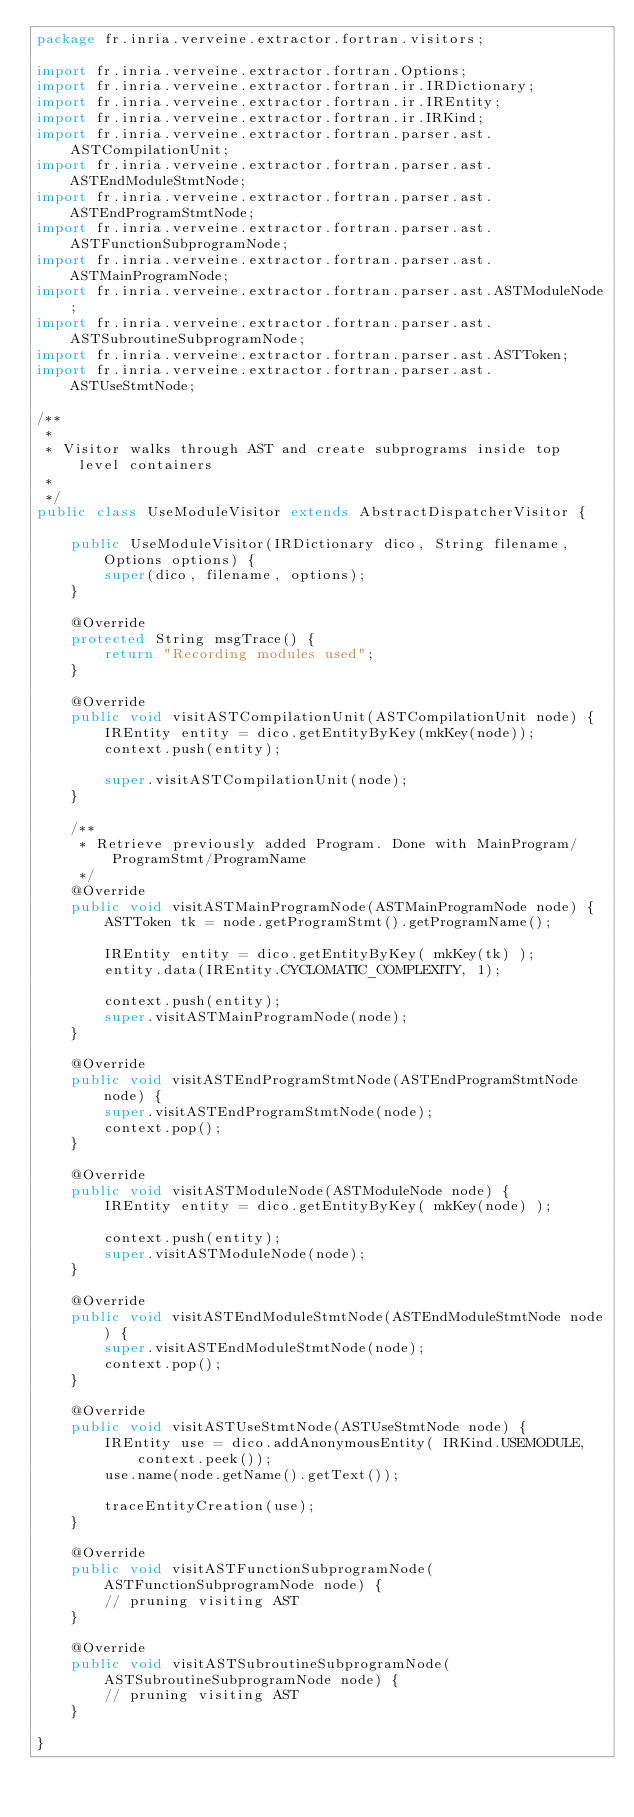<code> <loc_0><loc_0><loc_500><loc_500><_Java_>package fr.inria.verveine.extractor.fortran.visitors;

import fr.inria.verveine.extractor.fortran.Options;
import fr.inria.verveine.extractor.fortran.ir.IRDictionary;
import fr.inria.verveine.extractor.fortran.ir.IREntity;
import fr.inria.verveine.extractor.fortran.ir.IRKind;
import fr.inria.verveine.extractor.fortran.parser.ast.ASTCompilationUnit;
import fr.inria.verveine.extractor.fortran.parser.ast.ASTEndModuleStmtNode;
import fr.inria.verveine.extractor.fortran.parser.ast.ASTEndProgramStmtNode;
import fr.inria.verveine.extractor.fortran.parser.ast.ASTFunctionSubprogramNode;
import fr.inria.verveine.extractor.fortran.parser.ast.ASTMainProgramNode;
import fr.inria.verveine.extractor.fortran.parser.ast.ASTModuleNode;
import fr.inria.verveine.extractor.fortran.parser.ast.ASTSubroutineSubprogramNode;
import fr.inria.verveine.extractor.fortran.parser.ast.ASTToken;
import fr.inria.verveine.extractor.fortran.parser.ast.ASTUseStmtNode;

/**
 * 
 * Visitor walks through AST and create subprograms inside top level containers
 *
 */
public class UseModuleVisitor extends AbstractDispatcherVisitor {

	public UseModuleVisitor(IRDictionary dico, String filename, Options options) {
		super(dico, filename, options);
	}

	@Override
	protected String msgTrace() {
		return "Recording modules used";
	}

	@Override
	public void visitASTCompilationUnit(ASTCompilationUnit node) {
		IREntity entity = dico.getEntityByKey(mkKey(node));
		context.push(entity);

		super.visitASTCompilationUnit(node);
	}

	/**
	 * Retrieve previously added Program. Done with MainProgram/ProgramStmt/ProgramName
	 */
	@Override
	public void visitASTMainProgramNode(ASTMainProgramNode node) {
		ASTToken tk = node.getProgramStmt().getProgramName();

		IREntity entity = dico.getEntityByKey( mkKey(tk) );
		entity.data(IREntity.CYCLOMATIC_COMPLEXITY, 1);

		context.push(entity);
		super.visitASTMainProgramNode(node);
	}

	@Override
	public void visitASTEndProgramStmtNode(ASTEndProgramStmtNode node) {
		super.visitASTEndProgramStmtNode(node);
		context.pop();
	}

	@Override
	public void visitASTModuleNode(ASTModuleNode node) {
		IREntity entity = dico.getEntityByKey( mkKey(node) );

		context.push(entity);
		super.visitASTModuleNode(node);
	}

	@Override
	public void visitASTEndModuleStmtNode(ASTEndModuleStmtNode node) {
		super.visitASTEndModuleStmtNode(node);
		context.pop();
	}

	@Override
	public void visitASTUseStmtNode(ASTUseStmtNode node) {
		IREntity use = dico.addAnonymousEntity( IRKind.USEMODULE, context.peek());
		use.name(node.getName().getText());

		traceEntityCreation(use);
	}

	@Override
	public void visitASTFunctionSubprogramNode(ASTFunctionSubprogramNode node) {
		// pruning visiting AST
	}

	@Override
	public void visitASTSubroutineSubprogramNode(ASTSubroutineSubprogramNode node) {
		// pruning visiting AST
	}

}
</code> 